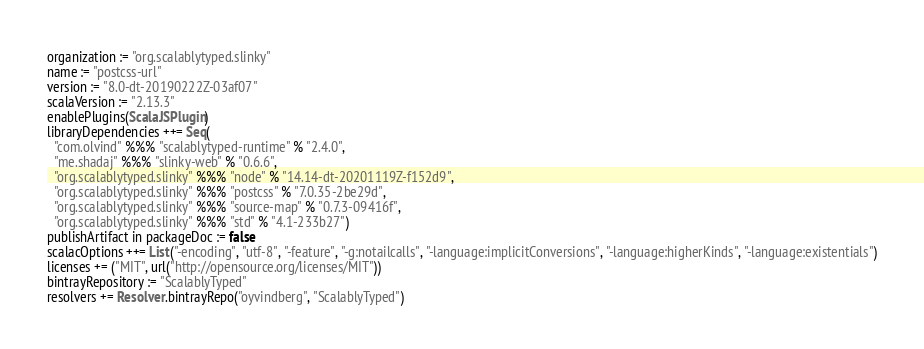<code> <loc_0><loc_0><loc_500><loc_500><_Scala_>organization := "org.scalablytyped.slinky"
name := "postcss-url"
version := "8.0-dt-20190222Z-03af07"
scalaVersion := "2.13.3"
enablePlugins(ScalaJSPlugin)
libraryDependencies ++= Seq(
  "com.olvind" %%% "scalablytyped-runtime" % "2.4.0",
  "me.shadaj" %%% "slinky-web" % "0.6.6",
  "org.scalablytyped.slinky" %%% "node" % "14.14-dt-20201119Z-f152d9",
  "org.scalablytyped.slinky" %%% "postcss" % "7.0.35-2be29d",
  "org.scalablytyped.slinky" %%% "source-map" % "0.7.3-09416f",
  "org.scalablytyped.slinky" %%% "std" % "4.1-233b27")
publishArtifact in packageDoc := false
scalacOptions ++= List("-encoding", "utf-8", "-feature", "-g:notailcalls", "-language:implicitConversions", "-language:higherKinds", "-language:existentials")
licenses += ("MIT", url("http://opensource.org/licenses/MIT"))
bintrayRepository := "ScalablyTyped"
resolvers += Resolver.bintrayRepo("oyvindberg", "ScalablyTyped")
</code> 